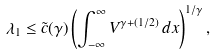<formula> <loc_0><loc_0><loc_500><loc_500>\lambda _ { 1 } \leq \tilde { c } ( \gamma ) \left ( \int _ { - \infty } ^ { \infty } V ^ { \gamma + ( 1 / 2 ) } \, d x \right ) ^ { 1 / \gamma } ,</formula> 